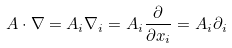<formula> <loc_0><loc_0><loc_500><loc_500>A \cdot \nabla = A _ { i } \nabla _ { i } = A _ { i } \frac { \partial } { \partial x _ { i } } = A _ { i } \partial _ { i }</formula> 